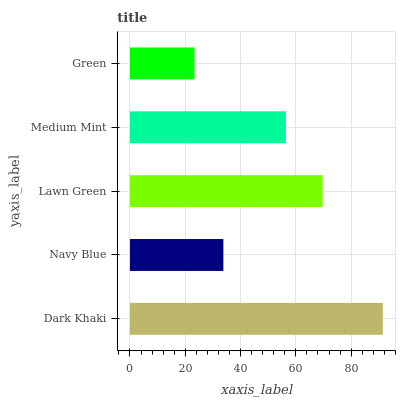Is Green the minimum?
Answer yes or no. Yes. Is Dark Khaki the maximum?
Answer yes or no. Yes. Is Navy Blue the minimum?
Answer yes or no. No. Is Navy Blue the maximum?
Answer yes or no. No. Is Dark Khaki greater than Navy Blue?
Answer yes or no. Yes. Is Navy Blue less than Dark Khaki?
Answer yes or no. Yes. Is Navy Blue greater than Dark Khaki?
Answer yes or no. No. Is Dark Khaki less than Navy Blue?
Answer yes or no. No. Is Medium Mint the high median?
Answer yes or no. Yes. Is Medium Mint the low median?
Answer yes or no. Yes. Is Navy Blue the high median?
Answer yes or no. No. Is Green the low median?
Answer yes or no. No. 